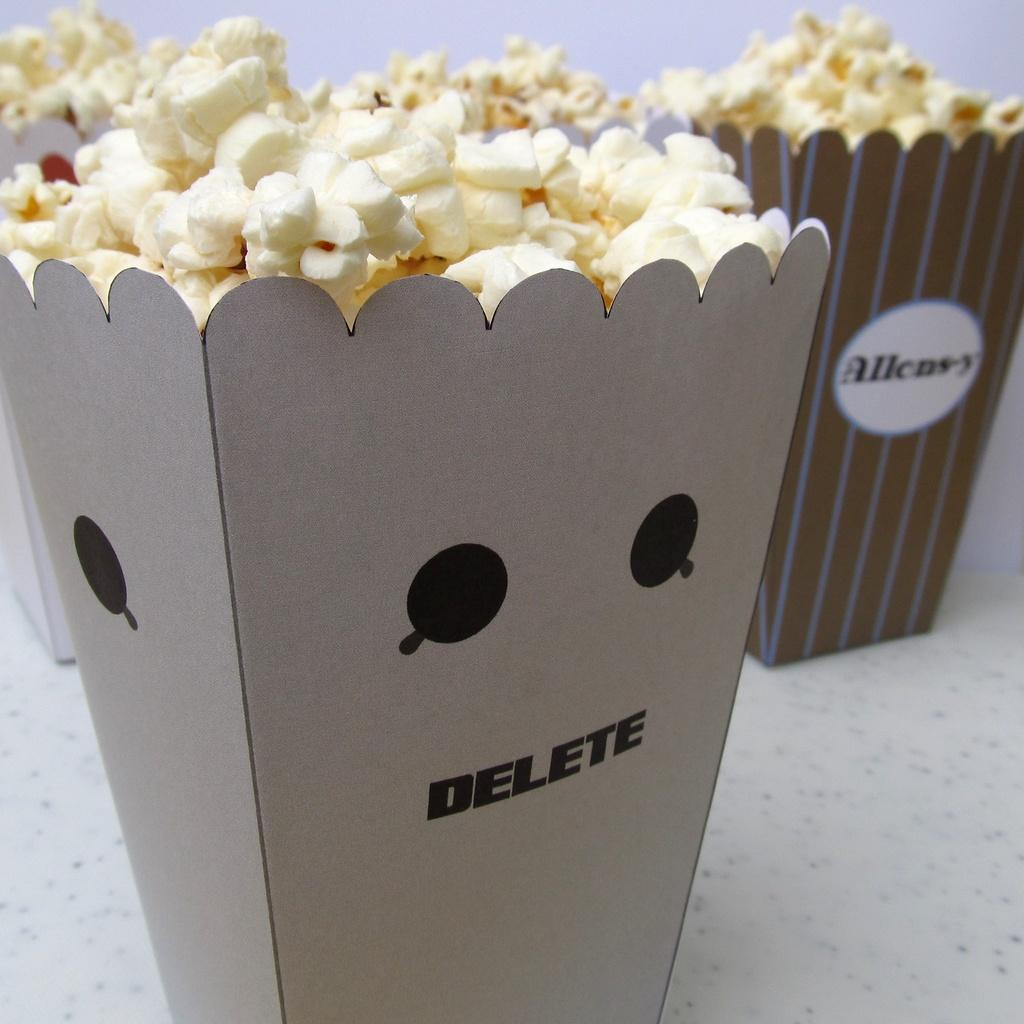What type of containers are visible on the white surface in the image? There are popcorn-buckets on a white color surface. What is the color of the surface where the containers are placed? The surface is white. What can be observed about the background of the image? The background of the image is white. Can you tell me how many flowers are present in the image? There are no flowers present in the image; it only features popcorn-buckets on a white surface. Is there a beggar visible in the image? There is no beggar present in the image; it only features popcorn-buckets on a white surface. 